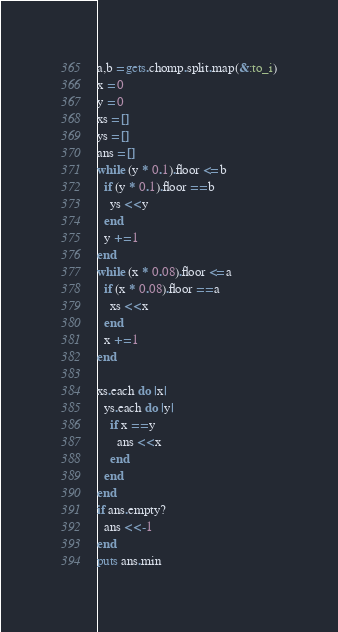<code> <loc_0><loc_0><loc_500><loc_500><_Ruby_>a,b = gets.chomp.split.map(&:to_i)
x = 0
y = 0
xs = []
ys = []
ans = []
while (y * 0.1).floor <= b
  if (y * 0.1).floor == b
    ys << y
  end
  y += 1
end
while (x * 0.08).floor <= a
  if (x * 0.08).floor == a
    xs << x
  end
  x += 1
end

xs.each do |x|
  ys.each do |y|
    if x == y
      ans << x
    end
  end
end
if ans.empty?
  ans << -1
end
puts ans.min</code> 